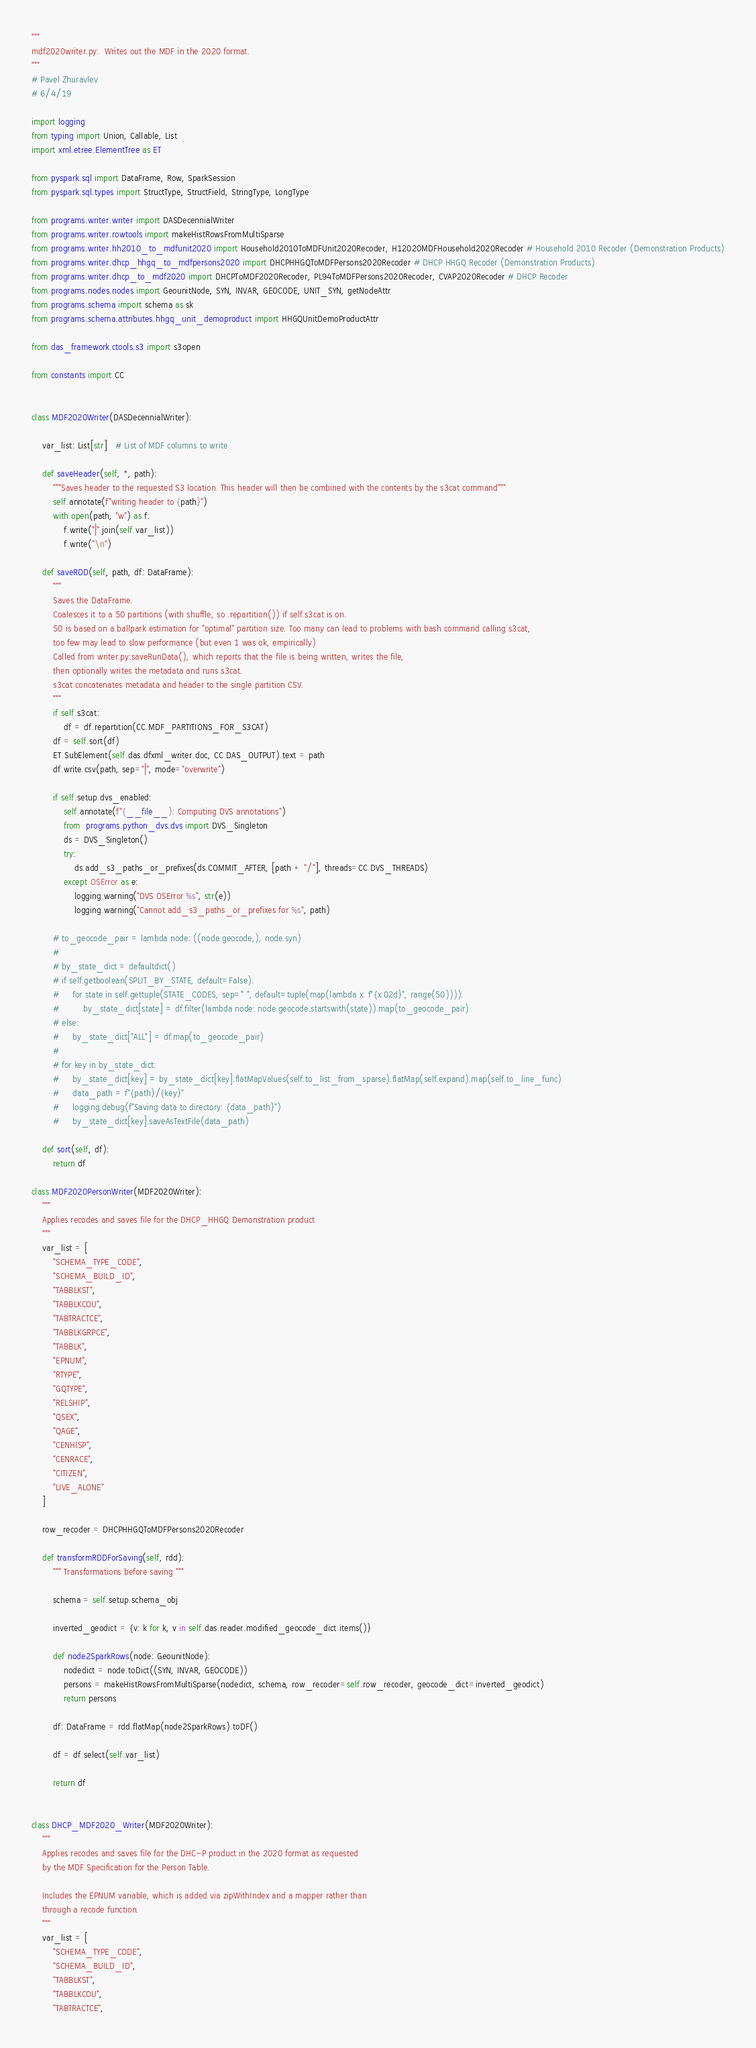Convert code to text. <code><loc_0><loc_0><loc_500><loc_500><_Python_>"""
mdf2020writer.py:  Writes out the MDF in the 2020 format.
"""
# Pavel Zhuravlev
# 6/4/19

import logging
from typing import Union, Callable, List
import xml.etree.ElementTree as ET

from pyspark.sql import DataFrame, Row, SparkSession
from pyspark.sql.types import StructType, StructField, StringType, LongType

from programs.writer.writer import DASDecennialWriter
from programs.writer.rowtools import makeHistRowsFromMultiSparse
from programs.writer.hh2010_to_mdfunit2020 import Household2010ToMDFUnit2020Recoder, H12020MDFHousehold2020Recoder # Household 2010 Recoder (Demonstration Products)
from programs.writer.dhcp_hhgq_to_mdfpersons2020 import DHCPHHGQToMDFPersons2020Recoder # DHCP HHGQ Recoder (Demonstration Products)
from programs.writer.dhcp_to_mdf2020 import DHCPToMDF2020Recoder, PL94ToMDFPersons2020Recoder, CVAP2020Recoder # DHCP Recoder
from programs.nodes.nodes import GeounitNode, SYN, INVAR, GEOCODE, UNIT_SYN, getNodeAttr
from programs.schema import schema as sk
from programs.schema.attributes.hhgq_unit_demoproduct import HHGQUnitDemoProductAttr

from das_framework.ctools.s3 import s3open

from constants import CC


class MDF2020Writer(DASDecennialWriter):

    var_list: List[str]   # List of MDF columns to write

    def saveHeader(self, *, path):
        """Saves header to the requested S3 location. This header will then be combined with the contents by the s3cat command"""
        self.annotate(f"writing header to {path}")
        with open(path, "w") as f:
            f.write("|".join(self.var_list))
            f.write("\n")

    def saveRDD(self, path, df: DataFrame):
        """
        Saves the DataFrame.
        Coalesces it to a 50 partitions (with shuffle, so .repartition()) if self.s3cat is on.
        50 is based on a ballpark estimation for "optimal" partition size. Too many can lead to problems with bash command calling s3cat,
        too few may lead to slow performance (but even 1 was ok, empirically)
        Called from writer.py:saveRunData(), which reports that the file is being written, writes the file,
        then optionally writes the metadata and runs s3cat.
        s3cat concatenates metadata and header to the single partition CSV.
        """
        if self.s3cat:
            df = df.repartition(CC.MDF_PARTITIONS_FOR_S3CAT)
        df = self.sort(df)
        ET.SubElement(self.das.dfxml_writer.doc, CC.DAS_OUTPUT).text = path
        df.write.csv(path, sep="|", mode="overwrite")

        if self.setup.dvs_enabled:
            self.annotate(f"{__file__}: Computing DVS annotations")
            from  programs.python_dvs.dvs import DVS_Singleton
            ds = DVS_Singleton()
            try:
                ds.add_s3_paths_or_prefixes(ds.COMMIT_AFTER, [path + "/"], threads=CC.DVS_THREADS)
            except OSError as e:
                logging.warning("DVS OSError %s", str(e))
                logging.warning("Cannot add_s3_paths_or_prefixes for %s", path)

        # to_geocode_pair = lambda node: ((node.geocode,), node.syn)
        #
        # by_state_dict = defaultdict()
        # if self.getboolean(SPLIT_BY_STATE, default=False):
        #     for state in self.gettuple(STATE_CODES, sep=" ", default=tuple(map(lambda x: f"{x:02d}", range(50)))):
        #         by_state_dict[state] = df.filter(lambda node: node.geocode.startswith(state)).map(to_geocode_pair)
        # else:
        #     by_state_dict["ALL"] = df.map(to_geocode_pair)
        #
        # for key in by_state_dict:
        #     by_state_dict[key] = by_state_dict[key].flatMapValues(self.to_list_from_sparse).flatMap(self.expand).map(self.to_line_func)
        #     data_path = f"{path}/{key}"
        #     logging.debug(f"Saving data to directory: {data_path}")
        #     by_state_dict[key].saveAsTextFile(data_path)

    def sort(self, df):
        return df

class MDF2020PersonWriter(MDF2020Writer):
    """
    Applies recodes and saves file for the DHCP_HHGQ Demonstration product
    """
    var_list = [
        "SCHEMA_TYPE_CODE",
        "SCHEMA_BUILD_ID",
        "TABBLKST",
        "TABBLKCOU",
        "TABTRACTCE",
        "TABBLKGRPCE",
        "TABBLK",
        "EPNUM",
        "RTYPE",
        "GQTYPE",
        "RELSHIP",
        "QSEX",
        "QAGE",
        "CENHISP",
        "CENRACE",
        "CITIZEN",
        "LIVE_ALONE"
    ]

    row_recoder = DHCPHHGQToMDFPersons2020Recoder

    def transformRDDForSaving(self, rdd):
        """ Transformations before saving """

        schema = self.setup.schema_obj

        inverted_geodict = {v: k for k, v in self.das.reader.modified_geocode_dict.items()}

        def node2SparkRows(node: GeounitNode):
            nodedict = node.toDict((SYN, INVAR, GEOCODE))
            persons = makeHistRowsFromMultiSparse(nodedict, schema, row_recoder=self.row_recoder, geocode_dict=inverted_geodict)
            return persons

        df: DataFrame = rdd.flatMap(node2SparkRows).toDF()

        df = df.select(self.var_list)

        return df


class DHCP_MDF2020_Writer(MDF2020Writer):
    """
    Applies recodes and saves file for the DHC-P product in the 2020 format as requested
    by the MDF Specification for the Person Table.

    Includes the EPNUM variable, which is added via zipWithIndex and a mapper rather than
    through a recode function.
    """
    var_list = [
        "SCHEMA_TYPE_CODE",
        "SCHEMA_BUILD_ID",
        "TABBLKST",
        "TABBLKCOU",
        "TABTRACTCE",</code> 